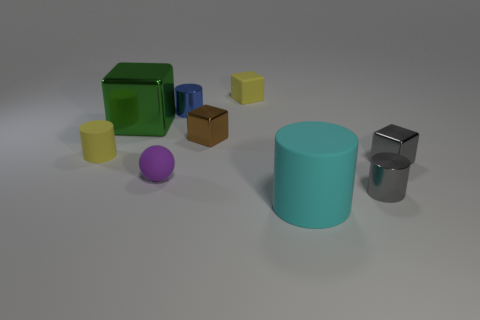There is a rubber object that is the same color as the small rubber cube; what is its shape?
Your answer should be very brief. Cylinder. Are any brown shiny blocks visible?
Offer a terse response. Yes. How many yellow rubber cubes have the same size as the purple matte sphere?
Give a very brief answer. 1. What number of tiny things are to the right of the tiny brown metallic object and behind the big green metal block?
Keep it short and to the point. 1. There is a metallic block that is behind the brown object; does it have the same size as the small purple rubber object?
Offer a terse response. No. Is there a tiny rubber sphere that has the same color as the big shiny thing?
Provide a short and direct response. No. There is a ball that is the same material as the big cylinder; what size is it?
Ensure brevity in your answer.  Small. Is the number of yellow cylinders that are behind the small rubber block greater than the number of blue things that are behind the green object?
Your response must be concise. No. How many other objects are the same material as the small purple thing?
Offer a terse response. 3. Are the yellow thing that is right of the purple thing and the purple object made of the same material?
Your answer should be compact. Yes. 